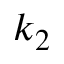<formula> <loc_0><loc_0><loc_500><loc_500>k _ { 2 }</formula> 